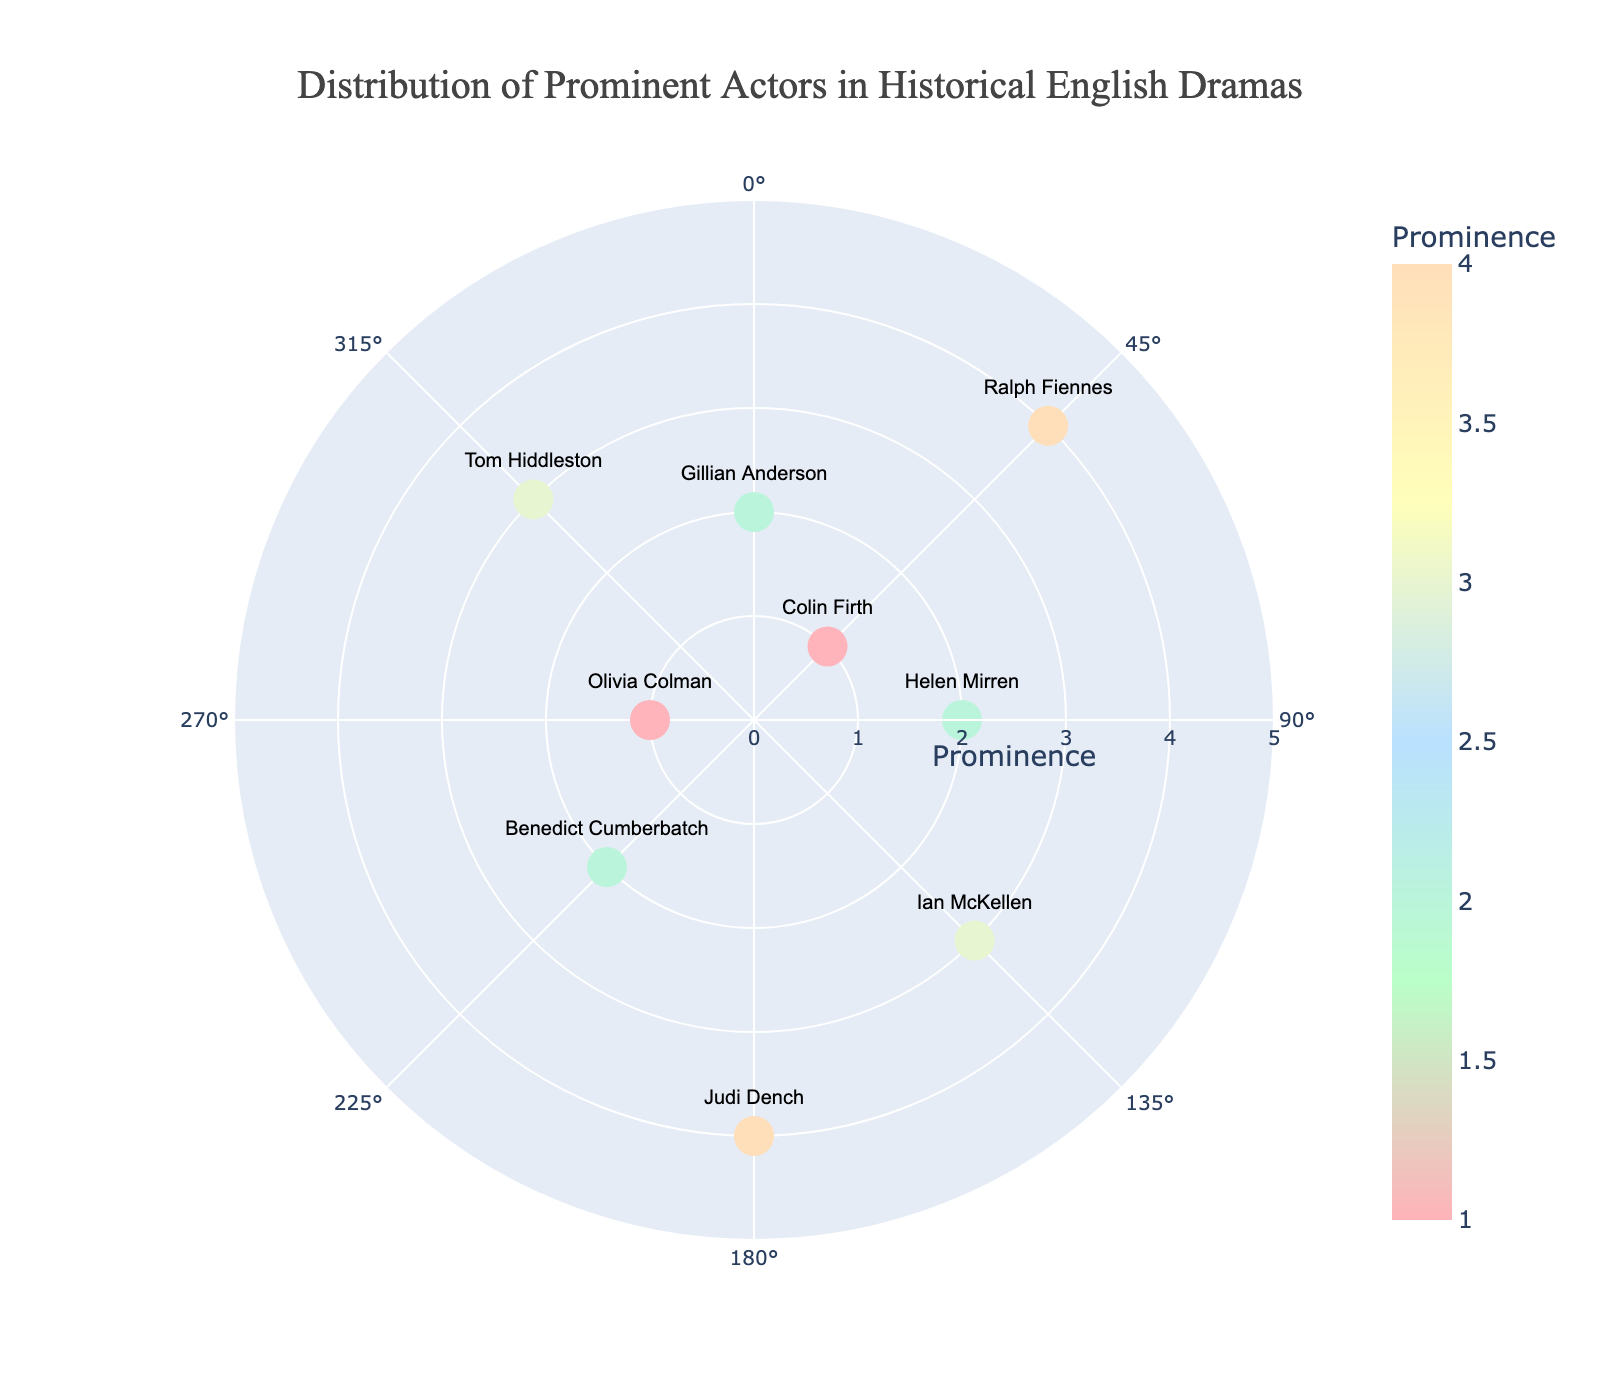How many actors are represented in the chart? Count the number of text labels (actors) displayed on the plot.
Answer: 9 Which actor has the highest prominence and what drama do they represent? Look for the actor with the highest radius value, here it is 4. The corresponding actor label is Judi Dench in "The Importance of Being Earnest".
Answer: Judi Dench, The Importance of Being Earnest What is the radial axis range in the figure? Identify the radial axis range shown in the plot, which goes from 0 to 5.
Answer: 0 to 5 Which actor plays the role of Hamlet and what is their prominence? Locate Benedict Cumberbatch at the angle 225° with a radius value of 2, representing his prominence.
Answer: Benedict Cumberbatch, 2 Compare the prominence of Tom Hiddleston in "The Hollow Crown" with Colin Firth in "Pride and Prejudice". Which actor has a higher prominence? Tom Hiddleston has a prominence radius of 3, while Colin Firth has a prominence radius of 1. Tom Hiddleston has a higher prominence.
Answer: Tom Hiddleston How many roles have a prominence of 2? Count data points where the radius is 2. These points correspond to Helen Mirren, Benedict Cumberbatch, and Gillian Anderson, so there are 3 roles.
Answer: 3 Among the actors with a prominence of 1, which drama does Olivia Colman represent? Locate actors with a radius of 1 and identify Olivia Colman. She represents "Fleabag".
Answer: Fleabag Identify the actor portrayed at an angle of 90 degrees. Locate the actor at the 90° position, which is Helen Mirren playing Queen Elizabeth II in "The Audience".
Answer: Helen Mirren What is the combined prominence of actors at the angles of 45° and 360°? Find the actors at angles 45° and 360° (Colin Firth and Ralph Fiennes both at 45°, and Gillian Anderson at 360°), then sum their radii (1 + 4 + 2). The combined prominence is 7.
Answer: 7 